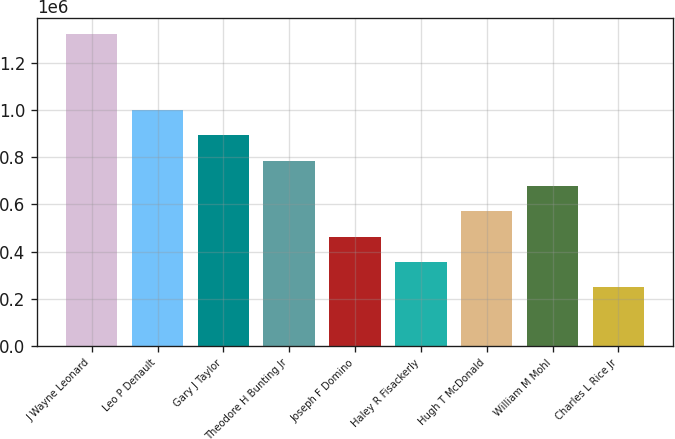<chart> <loc_0><loc_0><loc_500><loc_500><bar_chart><fcel>J Wayne Leonard<fcel>Leo P Denault<fcel>Gary J Taylor<fcel>Theodore H Bunting Jr<fcel>Joseph F Domino<fcel>Haley R Fisackerly<fcel>Hugh T McDonald<fcel>William M Mohl<fcel>Charles L Rice Jr<nl><fcel>1.3238e+06<fcel>1.00082e+06<fcel>893160<fcel>785500<fcel>462520<fcel>354860<fcel>570180<fcel>677840<fcel>247200<nl></chart> 